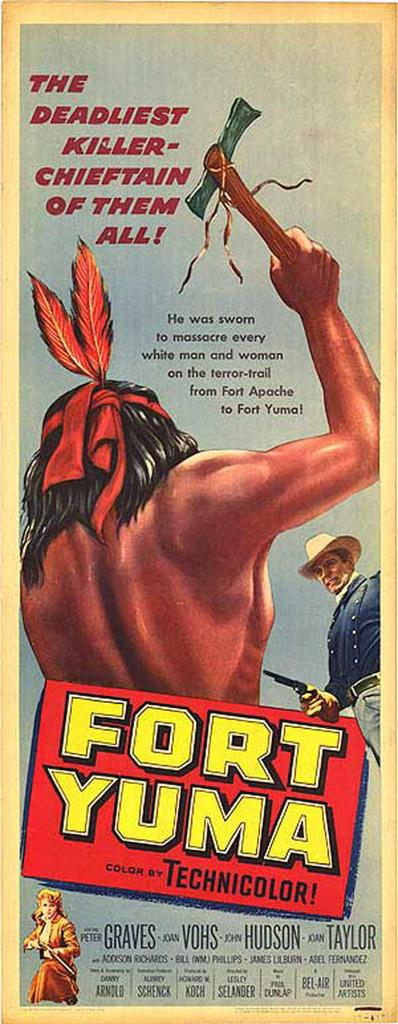What is featured on the poster in the image? There is writing on the poster. Can you describe the people in the image? The people in the image are holding weapons. What color are the eyes of the person on the left in the image? There is no information about the color of anyone's eyes in the image, as the facts provided do not mention anything about the people's eyes. 